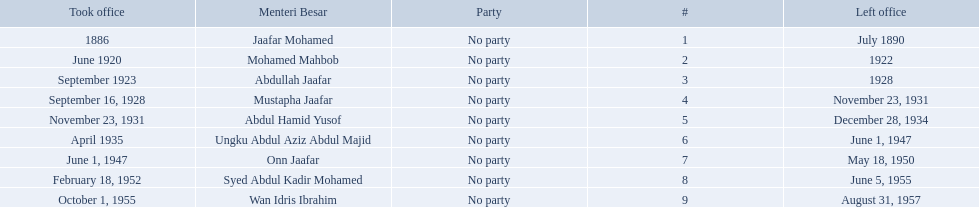Who are all of the menteri besars? Jaafar Mohamed, Mohamed Mahbob, Abdullah Jaafar, Mustapha Jaafar, Abdul Hamid Yusof, Ungku Abdul Aziz Abdul Majid, Onn Jaafar, Syed Abdul Kadir Mohamed, Wan Idris Ibrahim. When did each take office? 1886, June 1920, September 1923, September 16, 1928, November 23, 1931, April 1935, June 1, 1947, February 18, 1952, October 1, 1955. When did they leave? July 1890, 1922, 1928, November 23, 1931, December 28, 1934, June 1, 1947, May 18, 1950, June 5, 1955, August 31, 1957. And which spent the most time in office? Ungku Abdul Aziz Abdul Majid. Which menteri besars took office in the 1920's? Mohamed Mahbob, Abdullah Jaafar, Mustapha Jaafar. Of those men, who was only in office for 2 years? Mohamed Mahbob. When did jaafar mohamed take office? 1886. Could you help me parse every detail presented in this table? {'header': ['Took office', 'Menteri Besar', 'Party', '#', 'Left office'], 'rows': [['1886', 'Jaafar Mohamed', 'No party', '1', 'July 1890'], ['June 1920', 'Mohamed Mahbob', 'No party', '2', '1922'], ['September 1923', 'Abdullah Jaafar', 'No party', '3', '1928'], ['September 16, 1928', 'Mustapha Jaafar', 'No party', '4', 'November 23, 1931'], ['November 23, 1931', 'Abdul Hamid Yusof', 'No party', '5', 'December 28, 1934'], ['April 1935', 'Ungku Abdul Aziz Abdul Majid', 'No party', '6', 'June 1, 1947'], ['June 1, 1947', 'Onn Jaafar', 'No party', '7', 'May 18, 1950'], ['February 18, 1952', 'Syed Abdul Kadir Mohamed', 'No party', '8', 'June 5, 1955'], ['October 1, 1955', 'Wan Idris Ibrahim', 'No party', '9', 'August 31, 1957']]} When did mohamed mahbob take office? June 1920. Who was in office no more than 4 years? Mohamed Mahbob. 